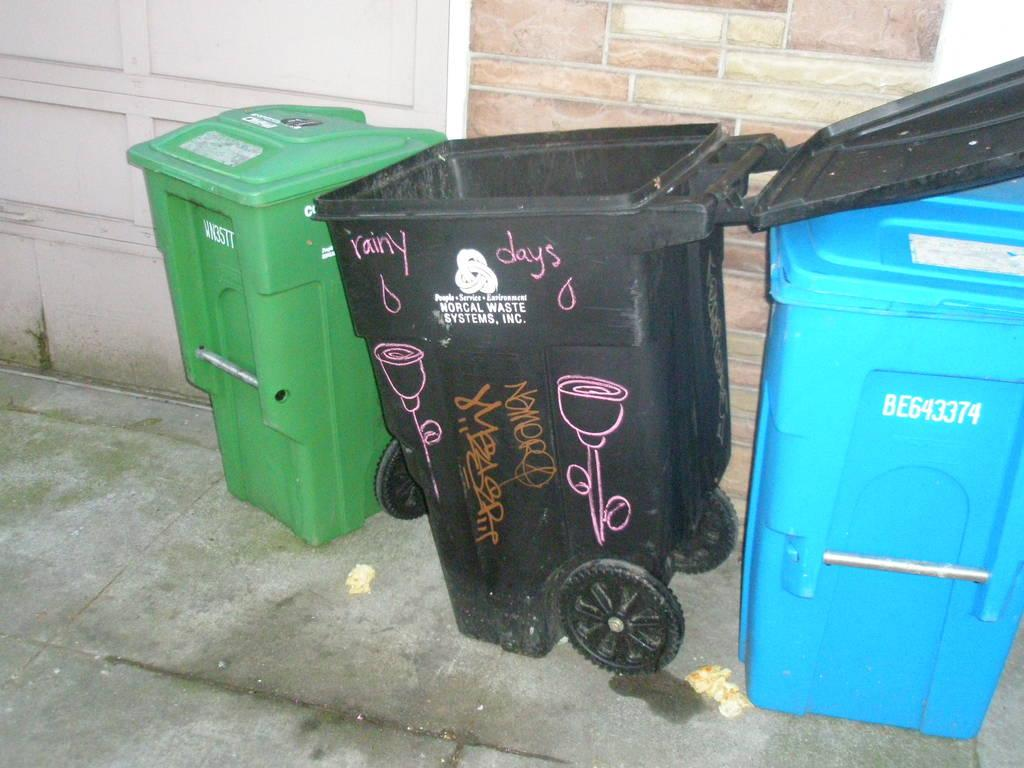<image>
Write a terse but informative summary of the picture. A trash can has the words "rainy days" on the side. 